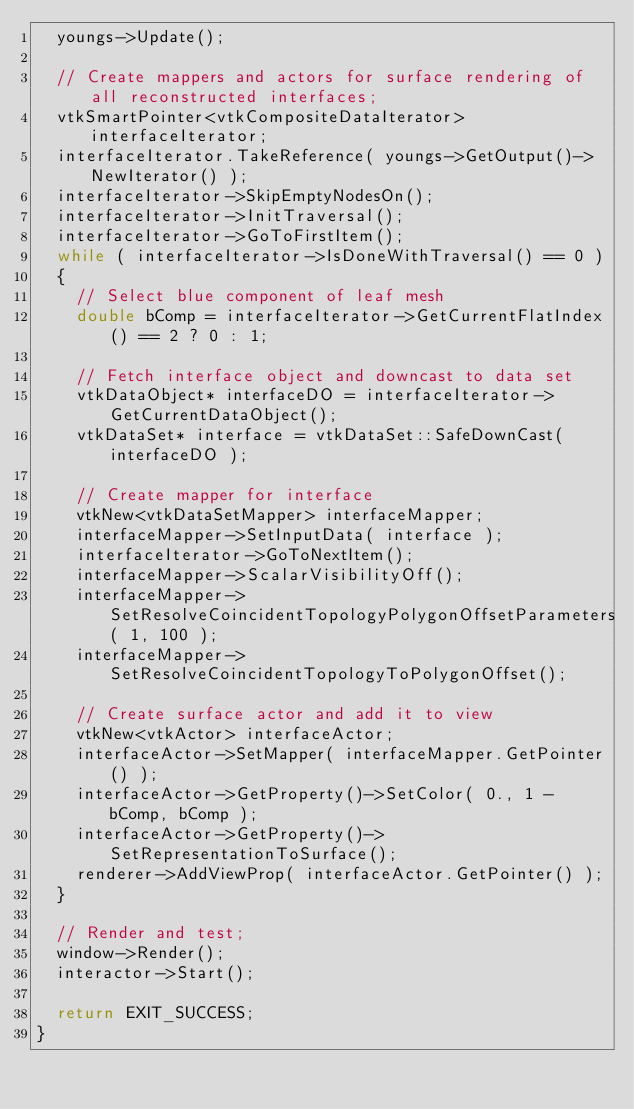<code> <loc_0><loc_0><loc_500><loc_500><_C++_>  youngs->Update();

  // Create mappers and actors for surface rendering of all reconstructed interfaces;
  vtkSmartPointer<vtkCompositeDataIterator> interfaceIterator;
  interfaceIterator.TakeReference( youngs->GetOutput()->NewIterator() );
  interfaceIterator->SkipEmptyNodesOn();
  interfaceIterator->InitTraversal();
  interfaceIterator->GoToFirstItem();
  while ( interfaceIterator->IsDoneWithTraversal() == 0 )
  {
    // Select blue component of leaf mesh
    double bComp = interfaceIterator->GetCurrentFlatIndex() == 2 ? 0 : 1;

    // Fetch interface object and downcast to data set
    vtkDataObject* interfaceDO = interfaceIterator->GetCurrentDataObject();
    vtkDataSet* interface = vtkDataSet::SafeDownCast( interfaceDO );

    // Create mapper for interface
    vtkNew<vtkDataSetMapper> interfaceMapper;
    interfaceMapper->SetInputData( interface );
    interfaceIterator->GoToNextItem();
    interfaceMapper->ScalarVisibilityOff();
    interfaceMapper->SetResolveCoincidentTopologyPolygonOffsetParameters( 1, 100 );
    interfaceMapper->SetResolveCoincidentTopologyToPolygonOffset();

    // Create surface actor and add it to view
    vtkNew<vtkActor> interfaceActor;
    interfaceActor->SetMapper( interfaceMapper.GetPointer() );
    interfaceActor->GetProperty()->SetColor( 0., 1 - bComp, bComp );
    interfaceActor->GetProperty()->SetRepresentationToSurface();
    renderer->AddViewProp( interfaceActor.GetPointer() );
  }

  // Render and test;
  window->Render();
  interactor->Start();

  return EXIT_SUCCESS;
}
</code> 